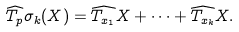<formula> <loc_0><loc_0><loc_500><loc_500>\widehat { T _ { p } } \sigma _ { k } ( X ) = \widehat { T _ { x _ { 1 } } } X + \dots + \widehat { T _ { x _ { k } } } X .</formula> 